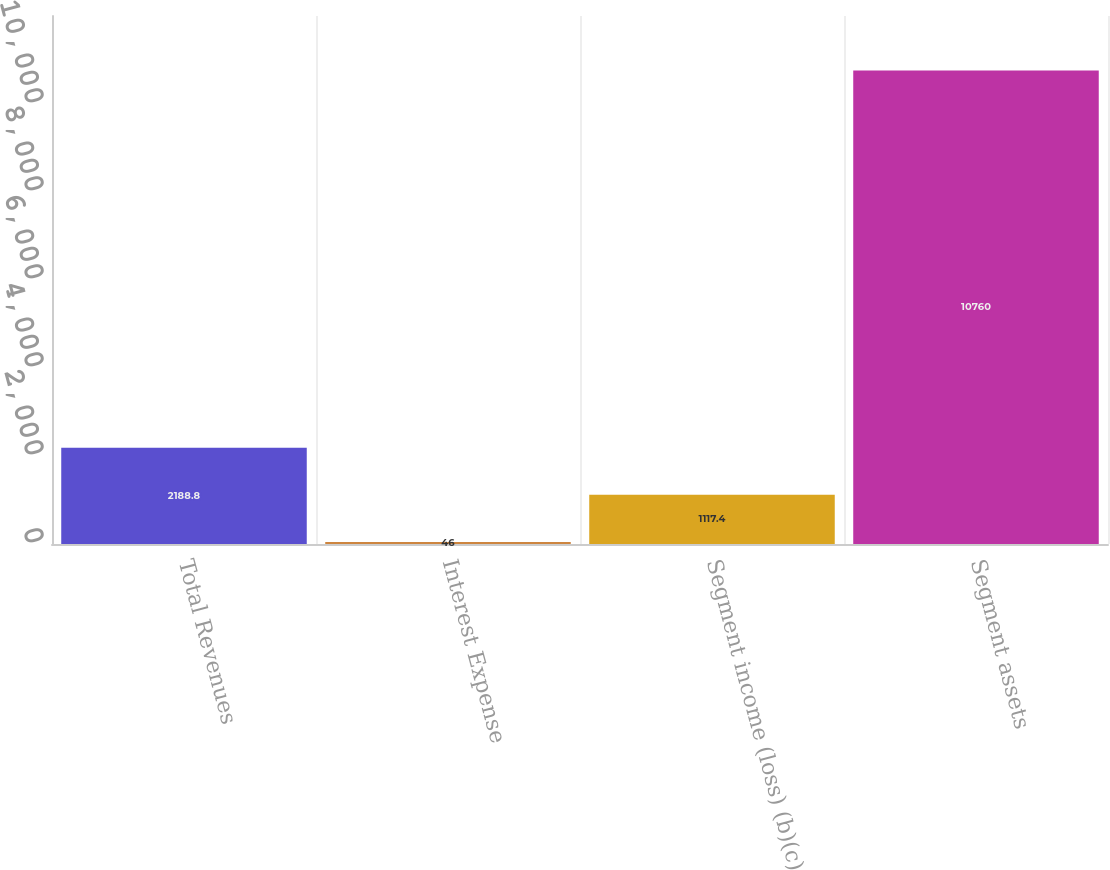Convert chart to OTSL. <chart><loc_0><loc_0><loc_500><loc_500><bar_chart><fcel>Total Revenues<fcel>Interest Expense<fcel>Segment income (loss) (b)(c)<fcel>Segment assets<nl><fcel>2188.8<fcel>46<fcel>1117.4<fcel>10760<nl></chart> 